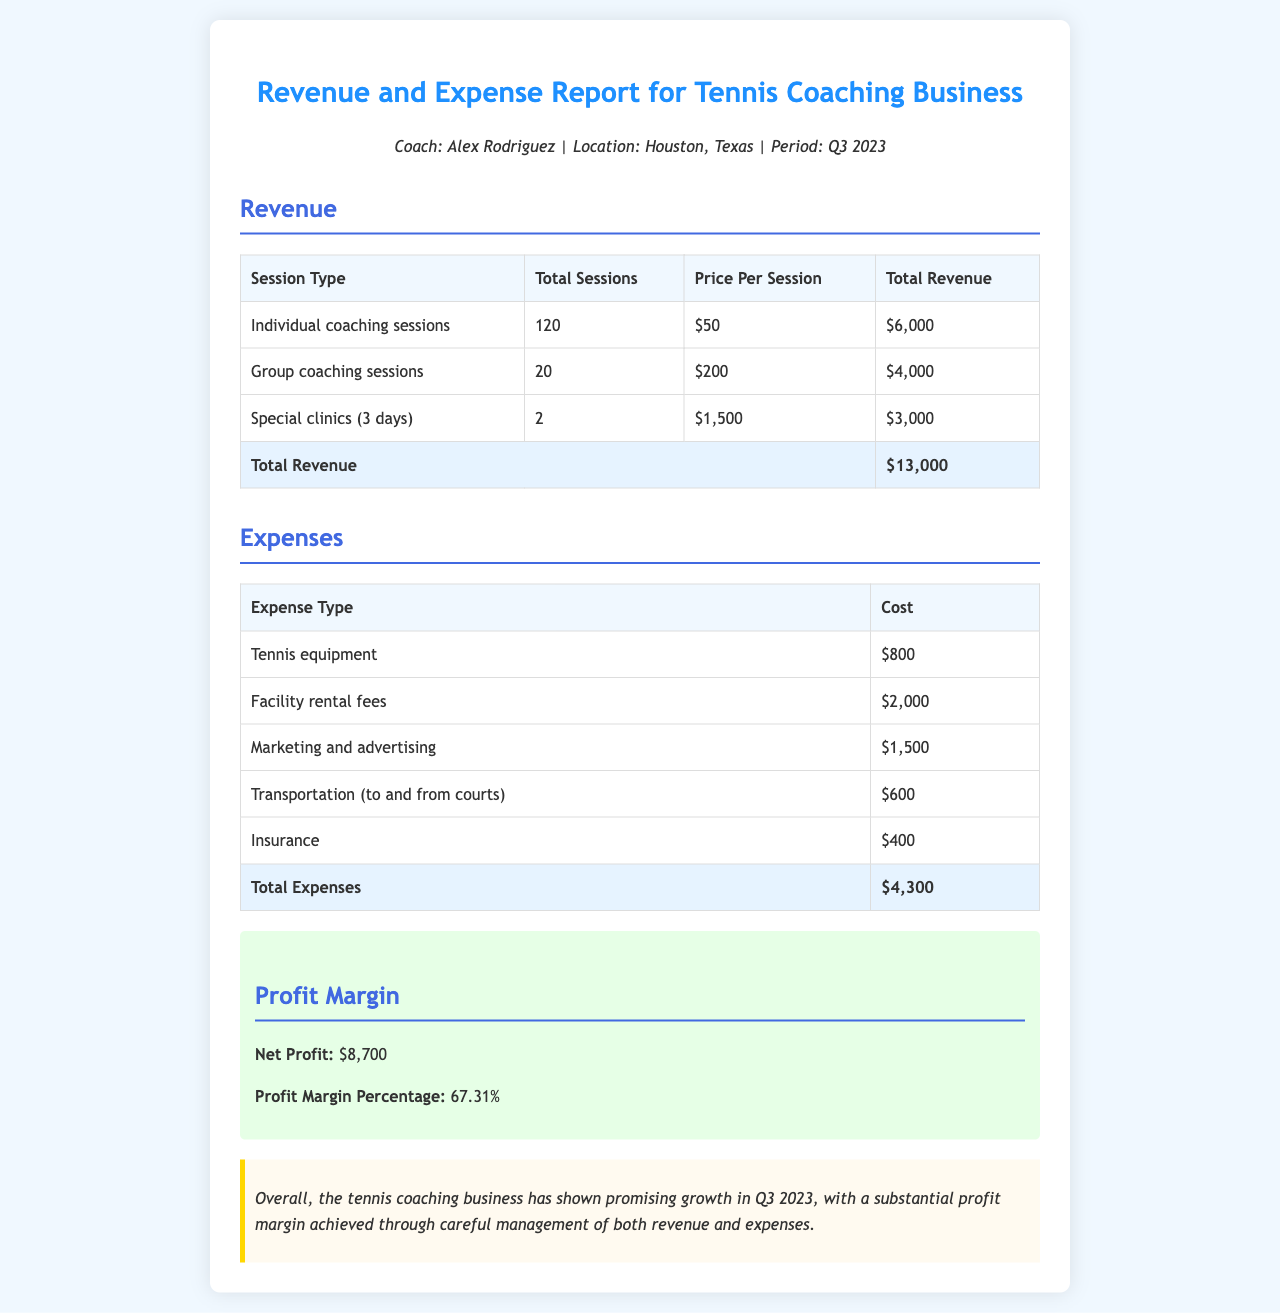What is the total revenue? The total revenue is the sum of all revenue sources: individual coaching, group coaching, and special clinics. The document states the total revenue is $13,000.
Answer: $13,000 How many individual coaching sessions were held? The document specifies that 120 individual coaching sessions were conducted.
Answer: 120 What was the cost of tennis equipment? According to the expenses table, the cost of tennis equipment is $800.
Answer: $800 What is the net profit for Q3 2023? The document shows that the net profit is derived from total revenue minus total expenses, which amounts to $8,700.
Answer: $8,700 What percentage represents the profit margin? The profit margin percentage is highlighted in the profit section as 67.31%.
Answer: 67.31% How much was spent on facility rental fees? The document lists the facility rental fees as $2,000 in the expenses section.
Answer: $2,000 How many special clinics were held? The document indicates that 2 special clinics were held during the quarter.
Answer: 2 Who is the coach mentioned in the report? The report identifies the coach as Alex Rodriguez.
Answer: Alex Rodriguez What was the total amount spent on marketing and advertising? The marketing and advertising expense is noted in the document as $1,500.
Answer: $1,500 